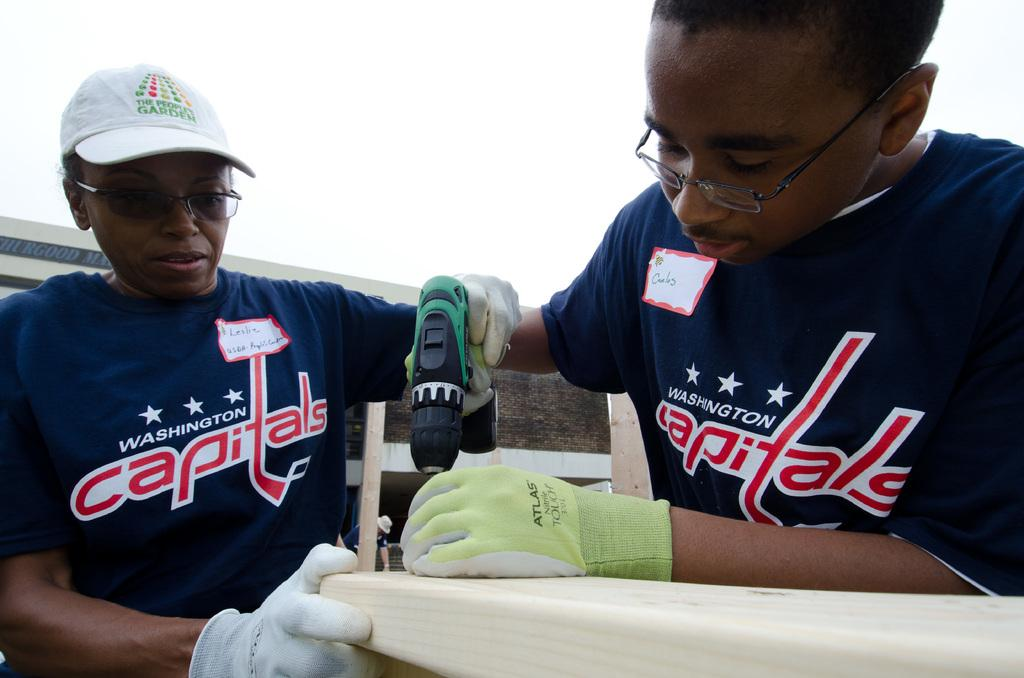How many people are in the image? There are two persons in the image. What are the persons wearing? Both persons are wearing blue t-shirts. What are the persons holding in their hands? The persons are holding a machine in their hands. What direction are the persons looking in? The persons are looking downwards. What is present at the bottom of the image? There is a table at the bottom of the image. What can be seen at the top of the image? The sky is visible at the top of the image. What type of memory is the person on the left using to operate the machine in the image? There is no indication in the image that the persons are using any specific type of memory to operate the machine. What type of expert is the person on the right in the image? There is no indication in the image that the person on the right is an expert in any specific field. 